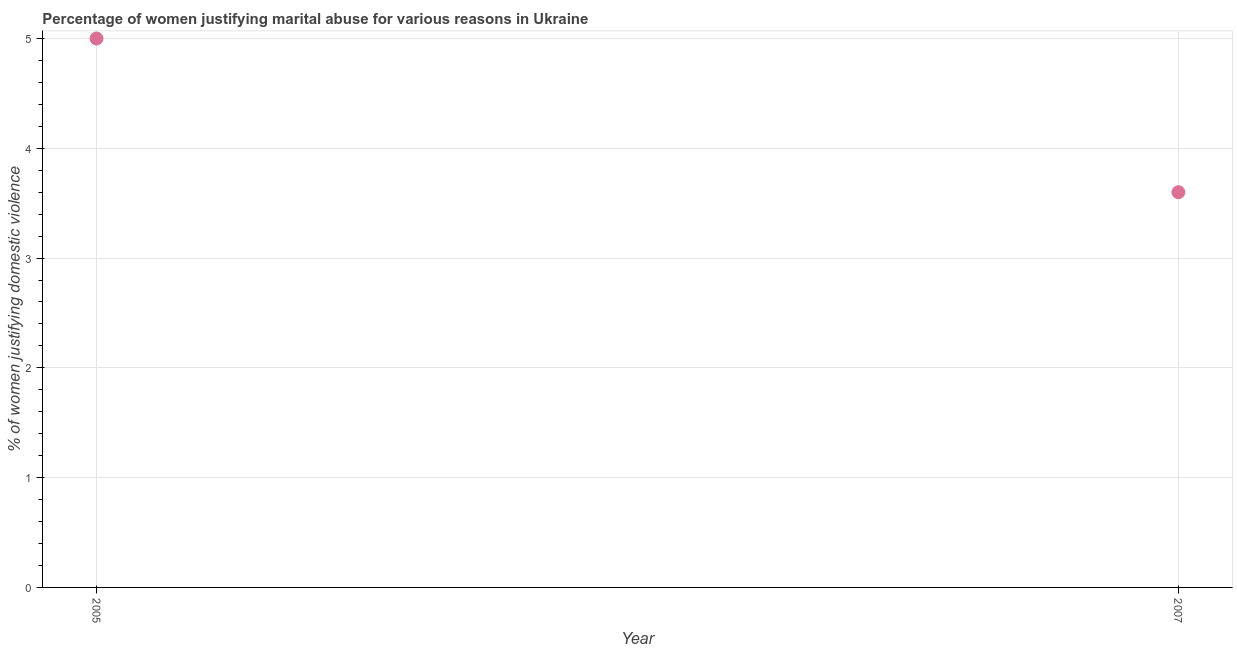What is the percentage of women justifying marital abuse in 2007?
Make the answer very short. 3.6. Across all years, what is the maximum percentage of women justifying marital abuse?
Keep it short and to the point. 5. In which year was the percentage of women justifying marital abuse minimum?
Make the answer very short. 2007. What is the sum of the percentage of women justifying marital abuse?
Keep it short and to the point. 8.6. What is the average percentage of women justifying marital abuse per year?
Provide a short and direct response. 4.3. Do a majority of the years between 2005 and 2007 (inclusive) have percentage of women justifying marital abuse greater than 2.8 %?
Your answer should be very brief. Yes. What is the ratio of the percentage of women justifying marital abuse in 2005 to that in 2007?
Offer a terse response. 1.39. Is the percentage of women justifying marital abuse in 2005 less than that in 2007?
Give a very brief answer. No. In how many years, is the percentage of women justifying marital abuse greater than the average percentage of women justifying marital abuse taken over all years?
Keep it short and to the point. 1. What is the difference between two consecutive major ticks on the Y-axis?
Your answer should be compact. 1. Are the values on the major ticks of Y-axis written in scientific E-notation?
Provide a succinct answer. No. Does the graph contain any zero values?
Give a very brief answer. No. Does the graph contain grids?
Keep it short and to the point. Yes. What is the title of the graph?
Your response must be concise. Percentage of women justifying marital abuse for various reasons in Ukraine. What is the label or title of the Y-axis?
Provide a succinct answer. % of women justifying domestic violence. What is the difference between the % of women justifying domestic violence in 2005 and 2007?
Your response must be concise. 1.4. What is the ratio of the % of women justifying domestic violence in 2005 to that in 2007?
Offer a terse response. 1.39. 